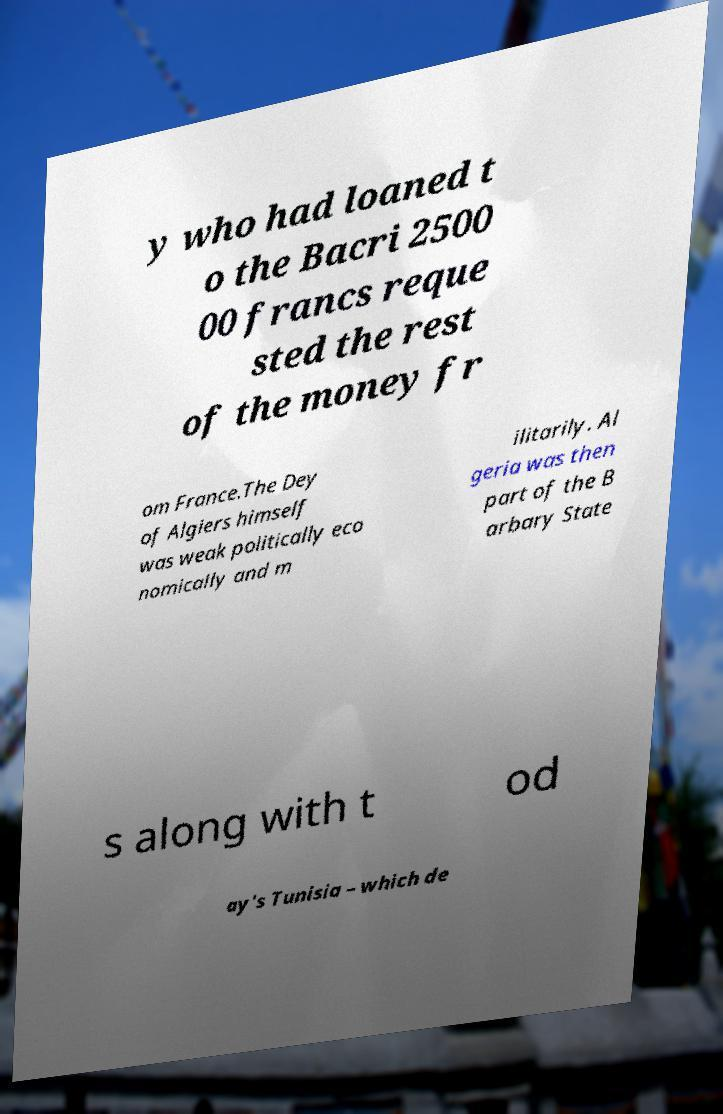Can you read and provide the text displayed in the image?This photo seems to have some interesting text. Can you extract and type it out for me? y who had loaned t o the Bacri 2500 00 francs reque sted the rest of the money fr om France.The Dey of Algiers himself was weak politically eco nomically and m ilitarily. Al geria was then part of the B arbary State s along with t od ay's Tunisia – which de 